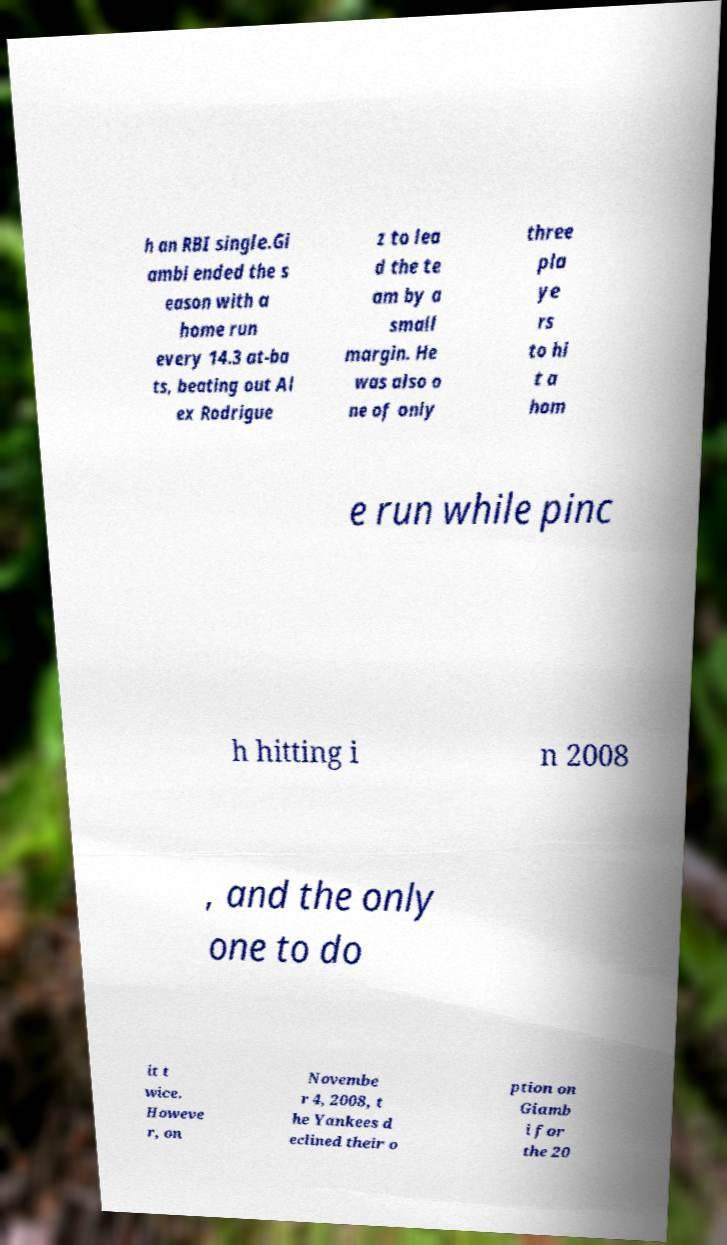Can you accurately transcribe the text from the provided image for me? h an RBI single.Gi ambi ended the s eason with a home run every 14.3 at-ba ts, beating out Al ex Rodrigue z to lea d the te am by a small margin. He was also o ne of only three pla ye rs to hi t a hom e run while pinc h hitting i n 2008 , and the only one to do it t wice. Howeve r, on Novembe r 4, 2008, t he Yankees d eclined their o ption on Giamb i for the 20 